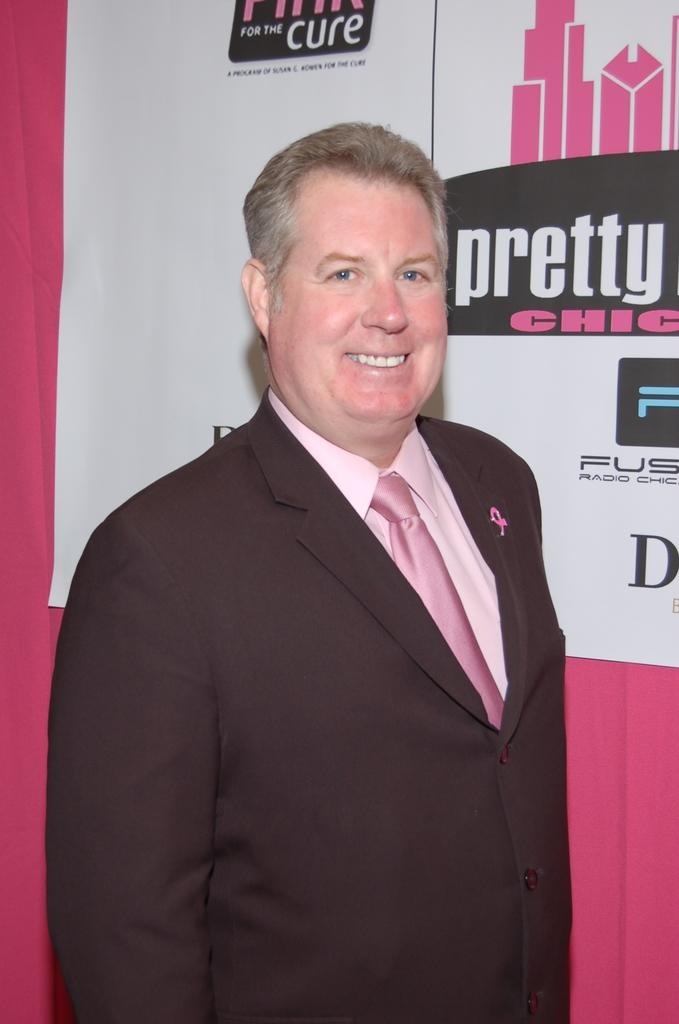<image>
Describe the image concisely. A man poses for a photo in front of a pink and white background that says pretty chic and for the cure. 